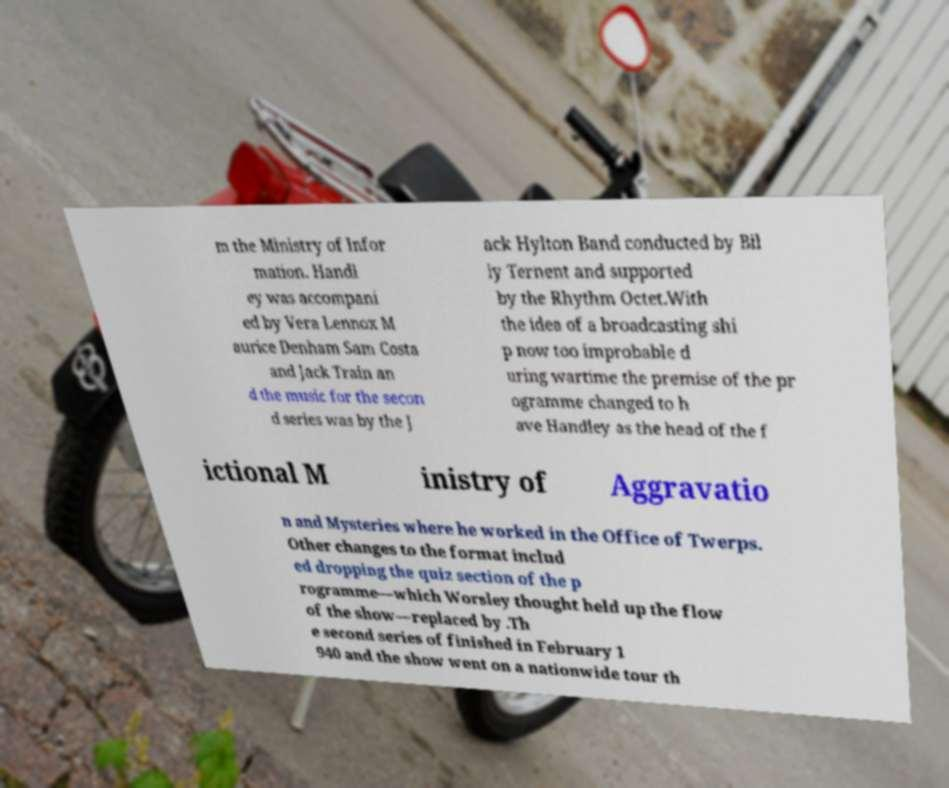Could you extract and type out the text from this image? m the Ministry of Infor mation. Handl ey was accompani ed by Vera Lennox M aurice Denham Sam Costa and Jack Train an d the music for the secon d series was by the J ack Hylton Band conducted by Bil ly Ternent and supported by the Rhythm Octet.With the idea of a broadcasting shi p now too improbable d uring wartime the premise of the pr ogramme changed to h ave Handley as the head of the f ictional M inistry of Aggravatio n and Mysteries where he worked in the Office of Twerps. Other changes to the format includ ed dropping the quiz section of the p rogramme—which Worsley thought held up the flow of the show—replaced by .Th e second series of finished in February 1 940 and the show went on a nationwide tour th 